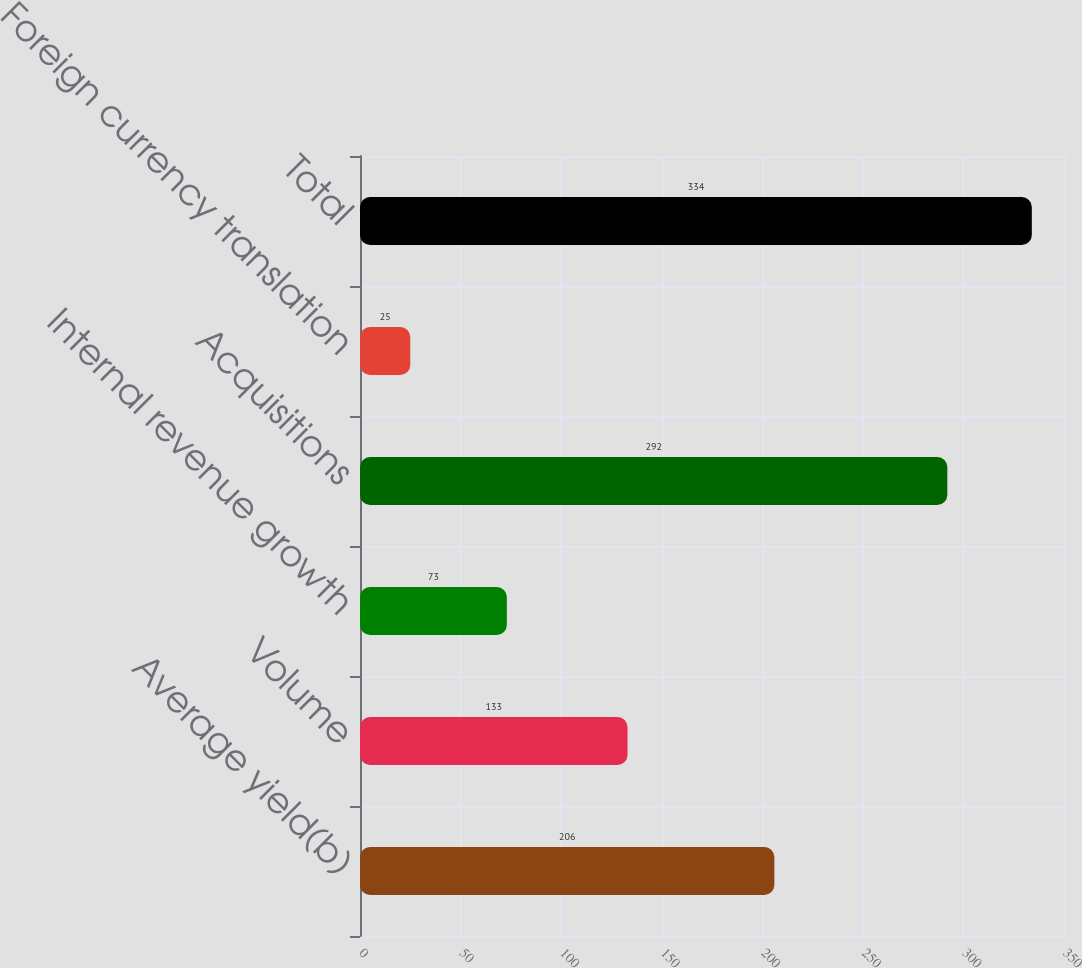<chart> <loc_0><loc_0><loc_500><loc_500><bar_chart><fcel>Average yield(b)<fcel>Volume<fcel>Internal revenue growth<fcel>Acquisitions<fcel>Foreign currency translation<fcel>Total<nl><fcel>206<fcel>133<fcel>73<fcel>292<fcel>25<fcel>334<nl></chart> 